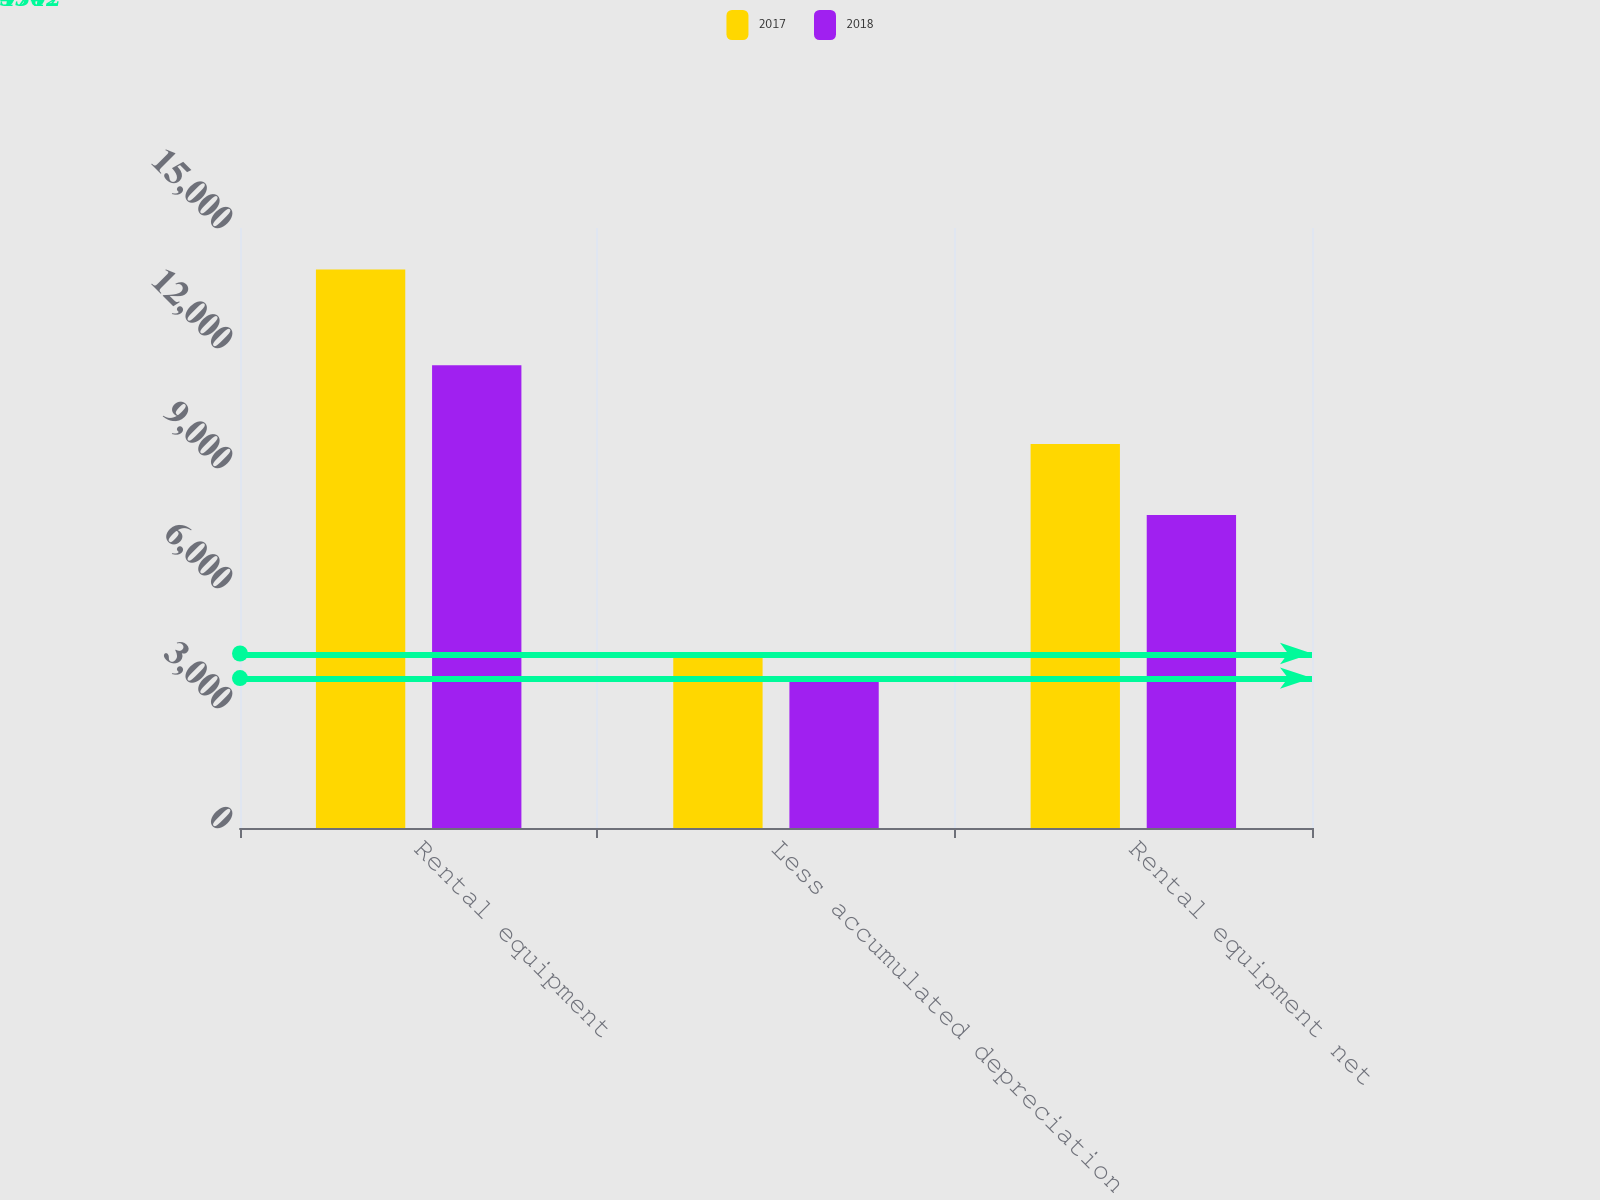Convert chart to OTSL. <chart><loc_0><loc_0><loc_500><loc_500><stacked_bar_chart><ecel><fcel>Rental equipment<fcel>Less accumulated depreciation<fcel>Rental equipment net<nl><fcel>2017<fcel>13962<fcel>4362<fcel>9600<nl><fcel>2018<fcel>11571<fcel>3747<fcel>7824<nl></chart> 